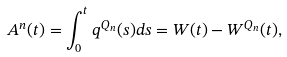<formula> <loc_0><loc_0><loc_500><loc_500>A ^ { n } ( t ) = \int _ { 0 } ^ { t } q ^ { Q _ { n } } ( s ) d s = W ( t ) - W ^ { Q _ { n } } ( t ) ,</formula> 